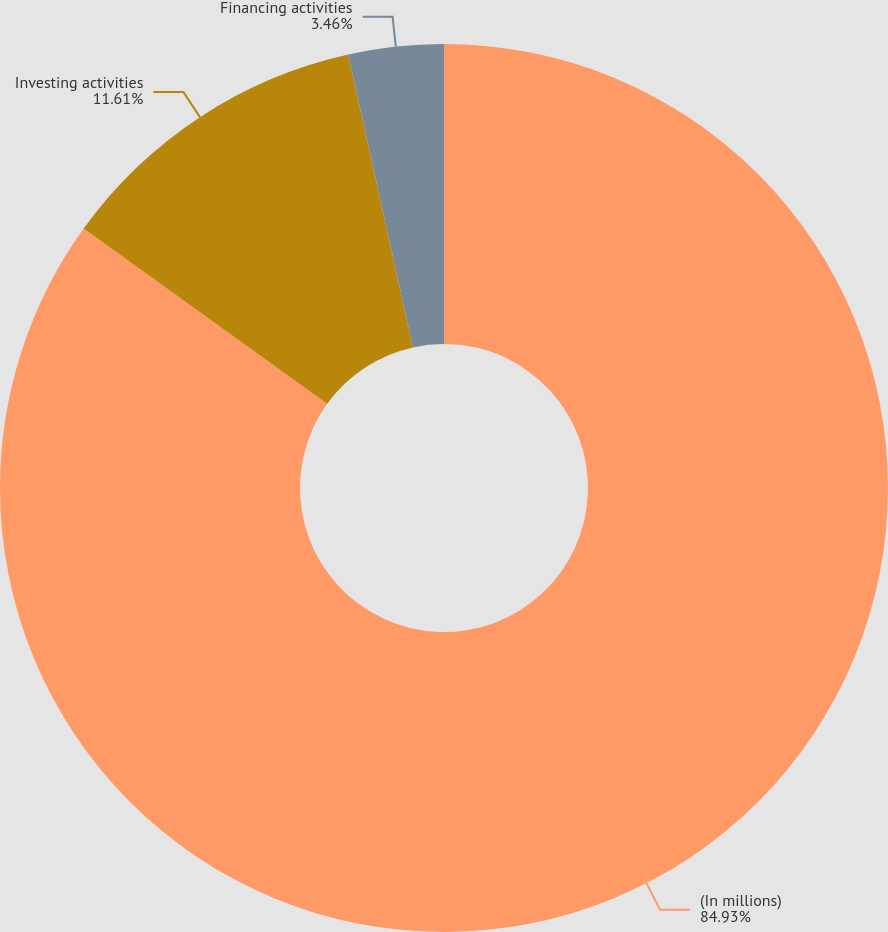Convert chart to OTSL. <chart><loc_0><loc_0><loc_500><loc_500><pie_chart><fcel>(In millions)<fcel>Investing activities<fcel>Financing activities<nl><fcel>84.93%<fcel>11.61%<fcel>3.46%<nl></chart> 